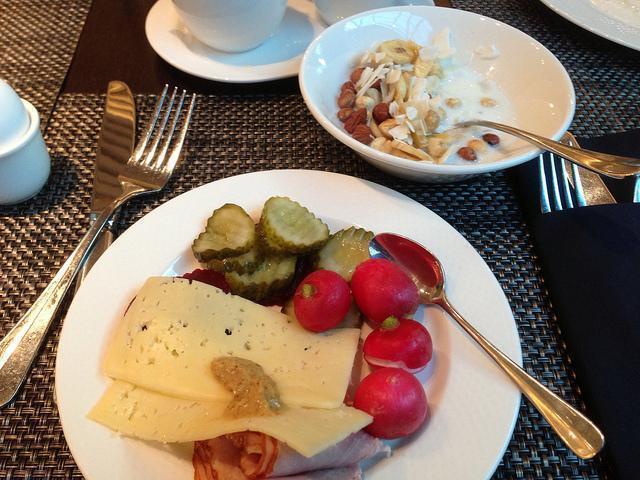What is the green stuff called on the plate?
From the following four choices, select the correct answer to address the question.
Options: Pea, corn, pickle, spinach. Pickle. 